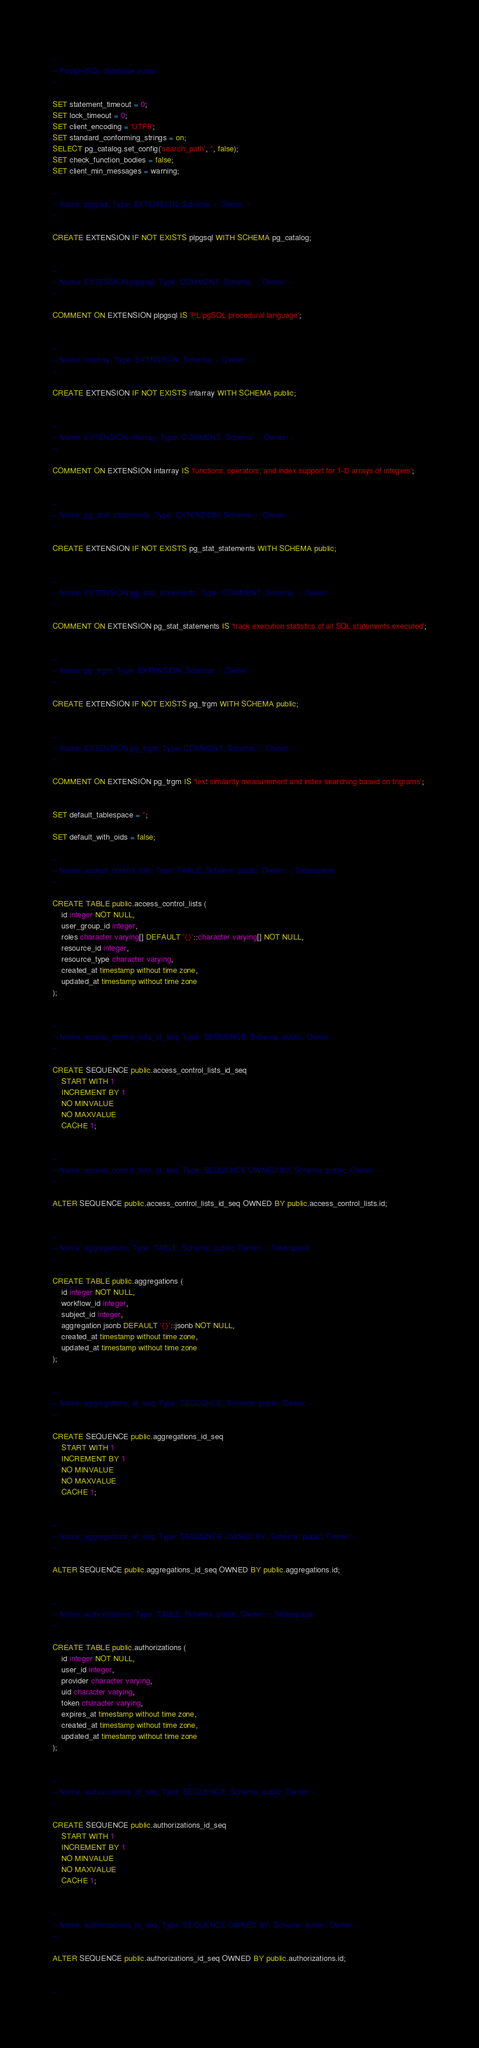Convert code to text. <code><loc_0><loc_0><loc_500><loc_500><_SQL_>--
-- PostgreSQL database dump
--

SET statement_timeout = 0;
SET lock_timeout = 0;
SET client_encoding = 'UTF8';
SET standard_conforming_strings = on;
SELECT pg_catalog.set_config('search_path', '', false);
SET check_function_bodies = false;
SET client_min_messages = warning;

--
-- Name: plpgsql; Type: EXTENSION; Schema: -; Owner: -
--

CREATE EXTENSION IF NOT EXISTS plpgsql WITH SCHEMA pg_catalog;


--
-- Name: EXTENSION plpgsql; Type: COMMENT; Schema: -; Owner: -
--

COMMENT ON EXTENSION plpgsql IS 'PL/pgSQL procedural language';


--
-- Name: intarray; Type: EXTENSION; Schema: -; Owner: -
--

CREATE EXTENSION IF NOT EXISTS intarray WITH SCHEMA public;


--
-- Name: EXTENSION intarray; Type: COMMENT; Schema: -; Owner: -
--

COMMENT ON EXTENSION intarray IS 'functions, operators, and index support for 1-D arrays of integers';


--
-- Name: pg_stat_statements; Type: EXTENSION; Schema: -; Owner: -
--

CREATE EXTENSION IF NOT EXISTS pg_stat_statements WITH SCHEMA public;


--
-- Name: EXTENSION pg_stat_statements; Type: COMMENT; Schema: -; Owner: -
--

COMMENT ON EXTENSION pg_stat_statements IS 'track execution statistics of all SQL statements executed';


--
-- Name: pg_trgm; Type: EXTENSION; Schema: -; Owner: -
--

CREATE EXTENSION IF NOT EXISTS pg_trgm WITH SCHEMA public;


--
-- Name: EXTENSION pg_trgm; Type: COMMENT; Schema: -; Owner: -
--

COMMENT ON EXTENSION pg_trgm IS 'text similarity measurement and index searching based on trigrams';


SET default_tablespace = '';

SET default_with_oids = false;

--
-- Name: access_control_lists; Type: TABLE; Schema: public; Owner: -; Tablespace: 
--

CREATE TABLE public.access_control_lists (
    id integer NOT NULL,
    user_group_id integer,
    roles character varying[] DEFAULT '{}'::character varying[] NOT NULL,
    resource_id integer,
    resource_type character varying,
    created_at timestamp without time zone,
    updated_at timestamp without time zone
);


--
-- Name: access_control_lists_id_seq; Type: SEQUENCE; Schema: public; Owner: -
--

CREATE SEQUENCE public.access_control_lists_id_seq
    START WITH 1
    INCREMENT BY 1
    NO MINVALUE
    NO MAXVALUE
    CACHE 1;


--
-- Name: access_control_lists_id_seq; Type: SEQUENCE OWNED BY; Schema: public; Owner: -
--

ALTER SEQUENCE public.access_control_lists_id_seq OWNED BY public.access_control_lists.id;


--
-- Name: aggregations; Type: TABLE; Schema: public; Owner: -; Tablespace: 
--

CREATE TABLE public.aggregations (
    id integer NOT NULL,
    workflow_id integer,
    subject_id integer,
    aggregation jsonb DEFAULT '{}'::jsonb NOT NULL,
    created_at timestamp without time zone,
    updated_at timestamp without time zone
);


--
-- Name: aggregations_id_seq; Type: SEQUENCE; Schema: public; Owner: -
--

CREATE SEQUENCE public.aggregations_id_seq
    START WITH 1
    INCREMENT BY 1
    NO MINVALUE
    NO MAXVALUE
    CACHE 1;


--
-- Name: aggregations_id_seq; Type: SEQUENCE OWNED BY; Schema: public; Owner: -
--

ALTER SEQUENCE public.aggregations_id_seq OWNED BY public.aggregations.id;


--
-- Name: authorizations; Type: TABLE; Schema: public; Owner: -; Tablespace: 
--

CREATE TABLE public.authorizations (
    id integer NOT NULL,
    user_id integer,
    provider character varying,
    uid character varying,
    token character varying,
    expires_at timestamp without time zone,
    created_at timestamp without time zone,
    updated_at timestamp without time zone
);


--
-- Name: authorizations_id_seq; Type: SEQUENCE; Schema: public; Owner: -
--

CREATE SEQUENCE public.authorizations_id_seq
    START WITH 1
    INCREMENT BY 1
    NO MINVALUE
    NO MAXVALUE
    CACHE 1;


--
-- Name: authorizations_id_seq; Type: SEQUENCE OWNED BY; Schema: public; Owner: -
--

ALTER SEQUENCE public.authorizations_id_seq OWNED BY public.authorizations.id;


--</code> 